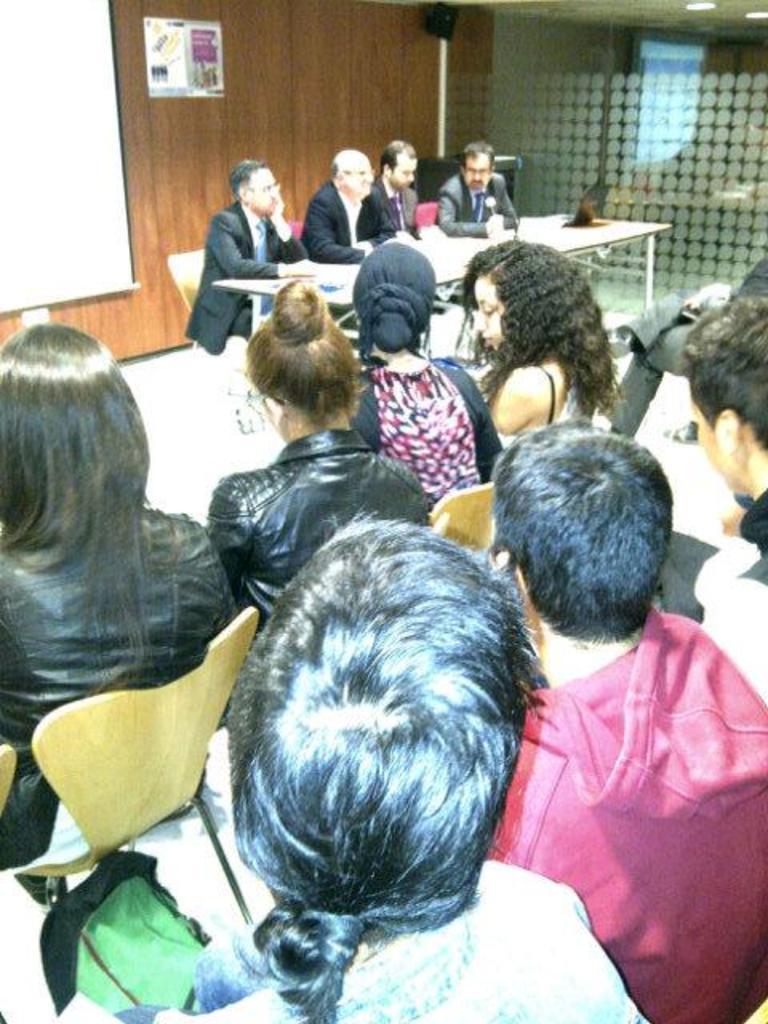Could you give a brief overview of what you see in this image? In this image we can see people are sitting on the chairs and there is a table. In the background we can see wall, glass, ceiling, lights, screen, and a poster. 